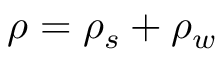Convert formula to latex. <formula><loc_0><loc_0><loc_500><loc_500>\rho = \rho _ { s } + \rho _ { w }</formula> 